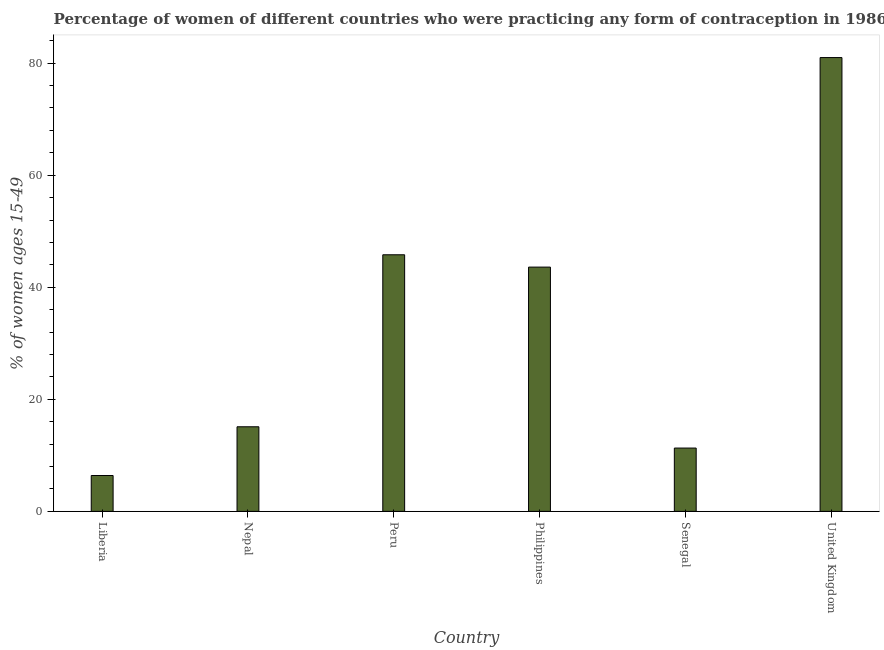What is the title of the graph?
Give a very brief answer. Percentage of women of different countries who were practicing any form of contraception in 1986. What is the label or title of the Y-axis?
Ensure brevity in your answer.  % of women ages 15-49. Across all countries, what is the maximum contraceptive prevalence?
Your answer should be very brief. 81. Across all countries, what is the minimum contraceptive prevalence?
Make the answer very short. 6.4. In which country was the contraceptive prevalence maximum?
Your answer should be compact. United Kingdom. In which country was the contraceptive prevalence minimum?
Your answer should be compact. Liberia. What is the sum of the contraceptive prevalence?
Your answer should be compact. 203.2. What is the difference between the contraceptive prevalence in Nepal and Peru?
Make the answer very short. -30.7. What is the average contraceptive prevalence per country?
Ensure brevity in your answer.  33.87. What is the median contraceptive prevalence?
Keep it short and to the point. 29.35. What is the ratio of the contraceptive prevalence in Liberia to that in Nepal?
Keep it short and to the point. 0.42. Is the difference between the contraceptive prevalence in Nepal and Senegal greater than the difference between any two countries?
Your answer should be very brief. No. What is the difference between the highest and the second highest contraceptive prevalence?
Provide a succinct answer. 35.2. What is the difference between the highest and the lowest contraceptive prevalence?
Keep it short and to the point. 74.6. Are all the bars in the graph horizontal?
Offer a terse response. No. What is the difference between two consecutive major ticks on the Y-axis?
Offer a terse response. 20. Are the values on the major ticks of Y-axis written in scientific E-notation?
Ensure brevity in your answer.  No. What is the % of women ages 15-49 of Liberia?
Give a very brief answer. 6.4. What is the % of women ages 15-49 of Nepal?
Your answer should be very brief. 15.1. What is the % of women ages 15-49 of Peru?
Your response must be concise. 45.8. What is the % of women ages 15-49 in Philippines?
Provide a short and direct response. 43.6. What is the % of women ages 15-49 of United Kingdom?
Your response must be concise. 81. What is the difference between the % of women ages 15-49 in Liberia and Nepal?
Your response must be concise. -8.7. What is the difference between the % of women ages 15-49 in Liberia and Peru?
Offer a very short reply. -39.4. What is the difference between the % of women ages 15-49 in Liberia and Philippines?
Your answer should be compact. -37.2. What is the difference between the % of women ages 15-49 in Liberia and United Kingdom?
Provide a short and direct response. -74.6. What is the difference between the % of women ages 15-49 in Nepal and Peru?
Ensure brevity in your answer.  -30.7. What is the difference between the % of women ages 15-49 in Nepal and Philippines?
Keep it short and to the point. -28.5. What is the difference between the % of women ages 15-49 in Nepal and United Kingdom?
Your answer should be very brief. -65.9. What is the difference between the % of women ages 15-49 in Peru and Senegal?
Provide a succinct answer. 34.5. What is the difference between the % of women ages 15-49 in Peru and United Kingdom?
Offer a terse response. -35.2. What is the difference between the % of women ages 15-49 in Philippines and Senegal?
Offer a terse response. 32.3. What is the difference between the % of women ages 15-49 in Philippines and United Kingdom?
Provide a succinct answer. -37.4. What is the difference between the % of women ages 15-49 in Senegal and United Kingdom?
Your answer should be compact. -69.7. What is the ratio of the % of women ages 15-49 in Liberia to that in Nepal?
Give a very brief answer. 0.42. What is the ratio of the % of women ages 15-49 in Liberia to that in Peru?
Your answer should be very brief. 0.14. What is the ratio of the % of women ages 15-49 in Liberia to that in Philippines?
Offer a very short reply. 0.15. What is the ratio of the % of women ages 15-49 in Liberia to that in Senegal?
Your response must be concise. 0.57. What is the ratio of the % of women ages 15-49 in Liberia to that in United Kingdom?
Ensure brevity in your answer.  0.08. What is the ratio of the % of women ages 15-49 in Nepal to that in Peru?
Offer a very short reply. 0.33. What is the ratio of the % of women ages 15-49 in Nepal to that in Philippines?
Keep it short and to the point. 0.35. What is the ratio of the % of women ages 15-49 in Nepal to that in Senegal?
Make the answer very short. 1.34. What is the ratio of the % of women ages 15-49 in Nepal to that in United Kingdom?
Give a very brief answer. 0.19. What is the ratio of the % of women ages 15-49 in Peru to that in Philippines?
Offer a terse response. 1.05. What is the ratio of the % of women ages 15-49 in Peru to that in Senegal?
Keep it short and to the point. 4.05. What is the ratio of the % of women ages 15-49 in Peru to that in United Kingdom?
Provide a succinct answer. 0.56. What is the ratio of the % of women ages 15-49 in Philippines to that in Senegal?
Ensure brevity in your answer.  3.86. What is the ratio of the % of women ages 15-49 in Philippines to that in United Kingdom?
Ensure brevity in your answer.  0.54. What is the ratio of the % of women ages 15-49 in Senegal to that in United Kingdom?
Give a very brief answer. 0.14. 